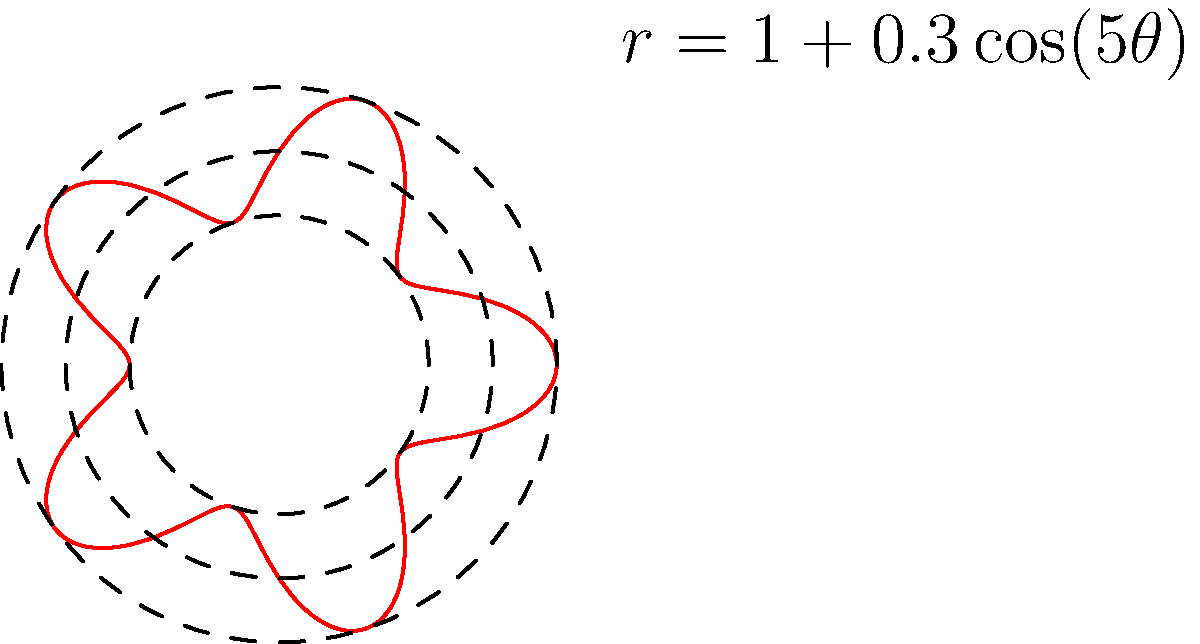In authenticating a circular mandala design, you discover that its outer edge follows the polar equation $r = 1 + 0.3\cos(5\theta)$. How many petals or lobes does this mandala design have, and what does this imply about its authenticity? To determine the number of petals or lobes in the mandala design, we need to analyze the given polar equation:

1. The equation is of the form $r = a + b\cos(n\theta)$, where:
   $a = 1$ (base radius)
   $b = 0.3$ (amplitude of the variation)
   $n = 5$ (frequency of the variation)

2. In polar equations, the value of $n$ determines the number of petals or lobes:
   - When $n$ is odd, the number of petals equals $n$.
   - When $n$ is even, the number of petals equals $2n$.

3. In this case, $n = 5$, which is odd.

4. Therefore, the mandala design has 5 petals or lobes.

5. Implications for authenticity:
   - The use of a 5-petal design is significant in many cultures and art traditions.
   - In Hinduism and Buddhism, the 5-petal lotus is a common symbol.
   - In Islamic art, 5-fold symmetry is often used in geometric patterns.
   - The precise mathematical nature of the design (following a specific polar equation) suggests a high level of sophistication in its creation.

6. The authenticity of the mandala can be supported by:
   - Verifying if the 5-petal design aligns with the purported cultural origin.
   - Checking if the level of mathematical precision in the design is consistent with the claimed period and origin of the artwork.
   - Comparing the design with other known authentic mandalas from the same tradition.
Answer: 5 petals; suggests sophisticated design consistent with various cultural traditions 